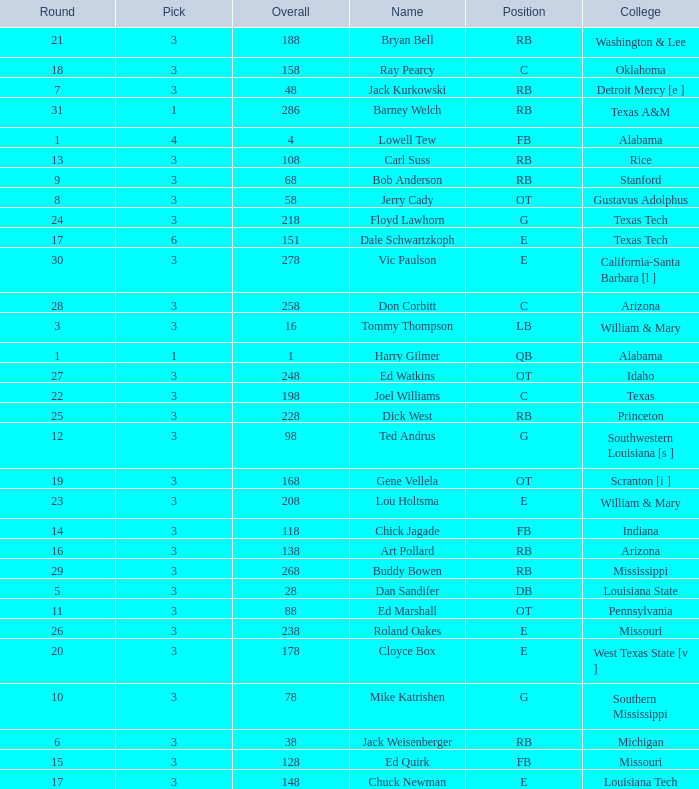How much Overall has a Name of bob anderson? 1.0. 